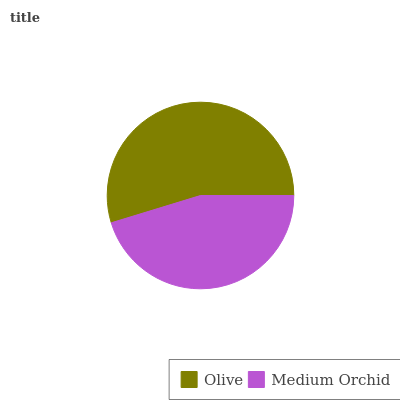Is Medium Orchid the minimum?
Answer yes or no. Yes. Is Olive the maximum?
Answer yes or no. Yes. Is Medium Orchid the maximum?
Answer yes or no. No. Is Olive greater than Medium Orchid?
Answer yes or no. Yes. Is Medium Orchid less than Olive?
Answer yes or no. Yes. Is Medium Orchid greater than Olive?
Answer yes or no. No. Is Olive less than Medium Orchid?
Answer yes or no. No. Is Olive the high median?
Answer yes or no. Yes. Is Medium Orchid the low median?
Answer yes or no. Yes. Is Medium Orchid the high median?
Answer yes or no. No. Is Olive the low median?
Answer yes or no. No. 